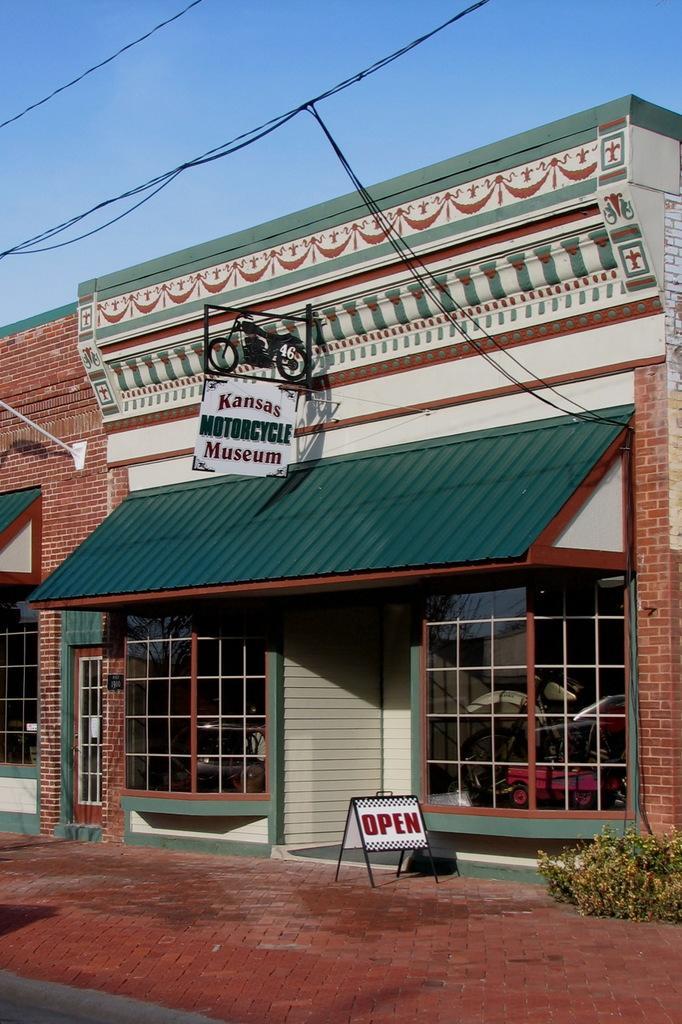Can you describe this image briefly? In this image I can see the store, board, few plants in green color and I can also see few glass doors and few buildings in brown and cream color. In the background I can see few wires and the sky is in blue and white color. 